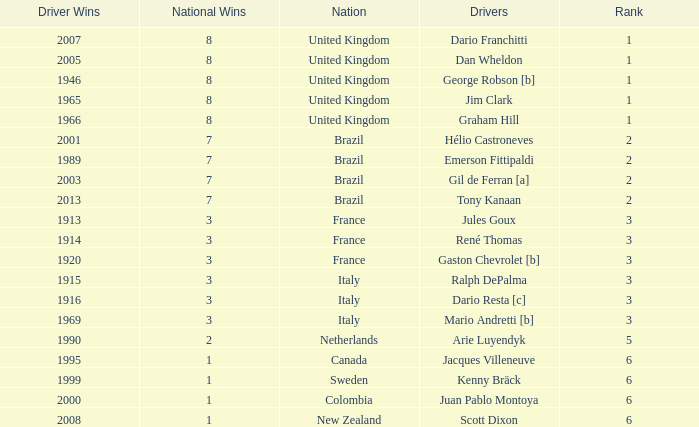What is the average number of wins of drivers from Sweden? 1999.0. 